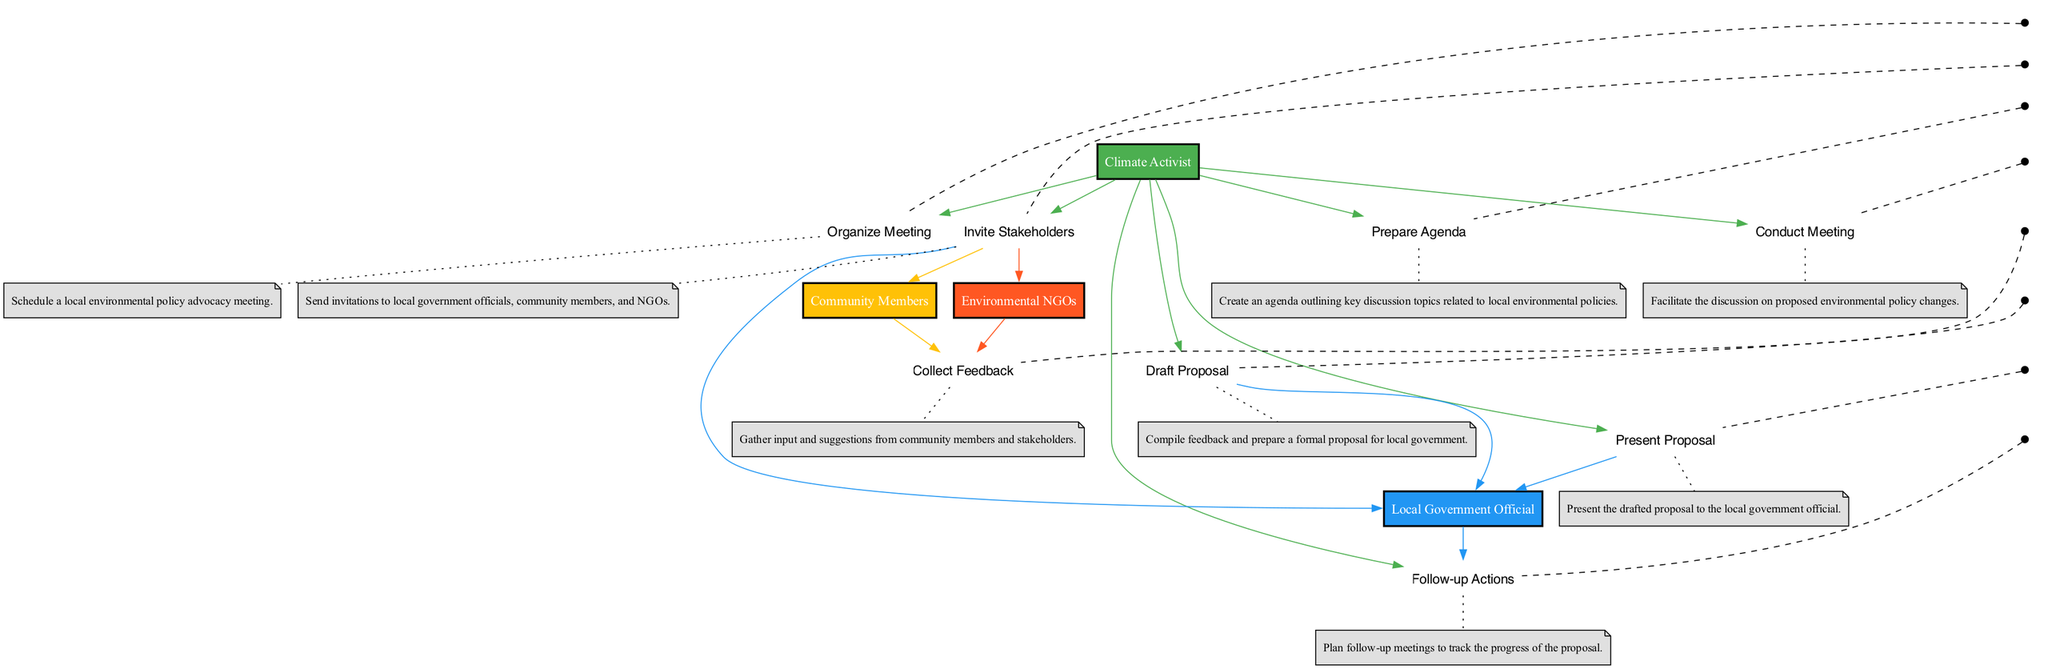What is the first action in the sequence? The first action in the sequence is "Organize Meeting", which is represented as the initial action node in the diagram, linked directly to the Climate Activist.
Answer: Organize Meeting How many actors are involved in the meeting sequence? There are four actors involved: Climate Activist, Local Government Official, Community Members, and Environmental NGOs. This can be determined by counting the unique actor nodes in the diagram.
Answer: Four Which actor is responsible for collecting feedback? The actor responsible for collecting feedback is the Community Members, as indicated by the direct line connecting them to the action node "Collect Feedback".
Answer: Community Members What is the action taken after "Conduct Meeting"? After "Conduct Meeting", the next action is "Collect Feedback", which follows logically in the sequence as shown by the connecting edge from "Conduct Meeting" to "Collect Feedback".
Answer: Collect Feedback Which actions does the Climate Activist perform? The Climate Activist performs four actions: "Organize Meeting", "Invite Stakeholders", "Prepare Agenda", and "Draft Proposal". These are visible by tracing the edges that connect the Climate Activist to the respective action nodes in the diagram.
Answer: Organize Meeting, Invite Stakeholders, Prepare Agenda, Draft Proposal What follows after the "Present Proposal" action? Following the "Present Proposal" action, the action "Follow-up Actions" takes place, as the timeline indicates a direct connection from "Present Proposal" to "Follow-up Actions".
Answer: Follow-up Actions Which actors are directly invited to the meeting? The actors directly invited to the meeting are Local Government Official, Community Members, and Environmental NGOs, as shown by the edges leading out from the "Invite Stakeholders" action to each of these actors.
Answer: Local Government Official, Community Members, Environmental NGOs How does "Draft Proposal" relate to the "Collect Feedback"? "Draft Proposal" relies on the input gathered during "Collect Feedback", meaning feedback from Community Members and Environmental NGOs is compiled to prepare a formal proposal, linking these two actions in a dependency relationship.
Answer: It depends on it 